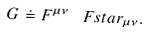Convert formula to latex. <formula><loc_0><loc_0><loc_500><loc_500>G \doteq F ^ { \mu \nu } \, \ F s t a r _ { \mu \nu } .</formula> 